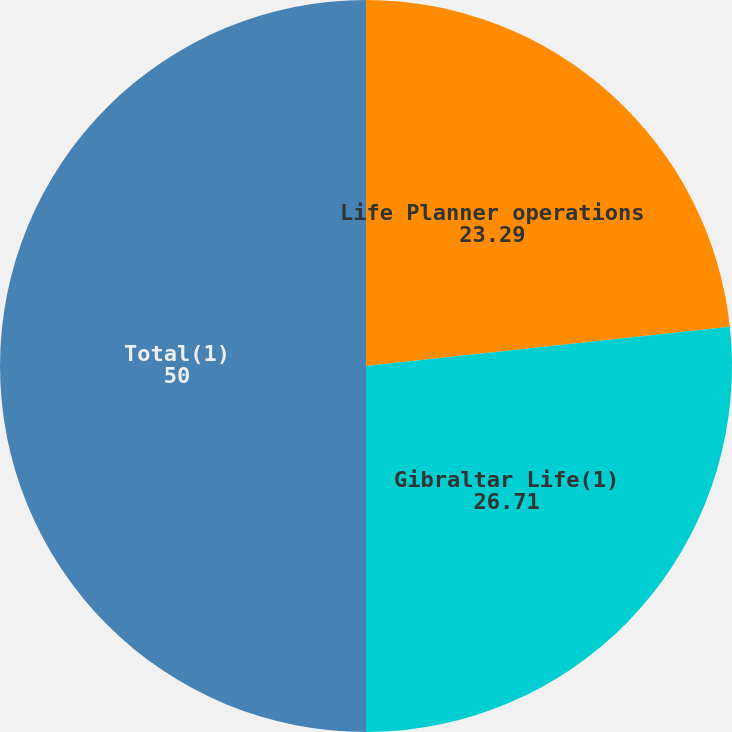Convert chart. <chart><loc_0><loc_0><loc_500><loc_500><pie_chart><fcel>Life Planner operations<fcel>Gibraltar Life(1)<fcel>Total(1)<nl><fcel>23.29%<fcel>26.71%<fcel>50.0%<nl></chart> 